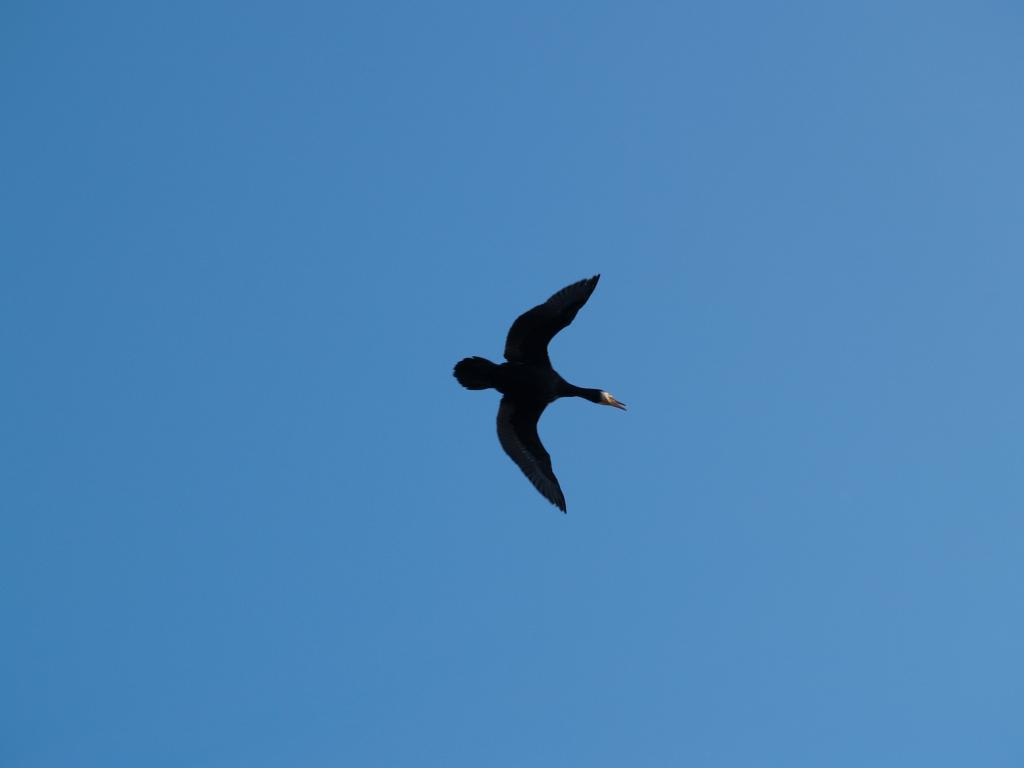What type of animal is in the image? There is a bird in the image. What color is the bird? The bird is black in color. What is the bird doing in the image? The bird is flying in the air. What can be seen in the background of the image? The sky is visible in the background of the image. What color is the sky? The sky is blue in color. Does the bird have an owner in the image? There is no indication of an owner for the bird in the image. What type of cushion is the bird sitting on in the image? There is no cushion present in the image; the bird is flying in the air. 